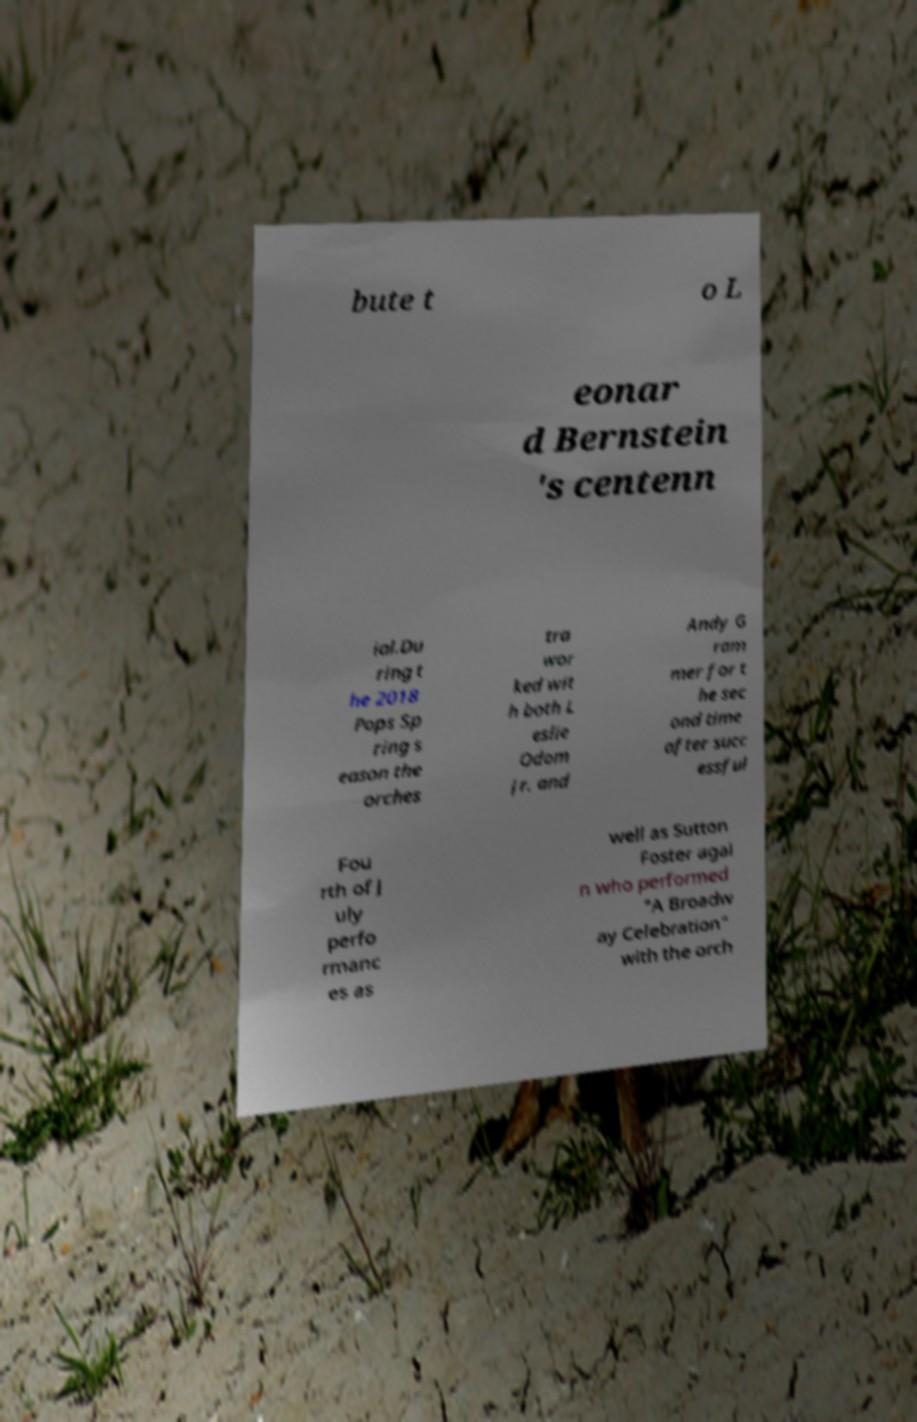Can you read and provide the text displayed in the image?This photo seems to have some interesting text. Can you extract and type it out for me? bute t o L eonar d Bernstein 's centenn ial.Du ring t he 2018 Pops Sp ring s eason the orches tra wor ked wit h both L eslie Odom Jr. and Andy G ram mer for t he sec ond time after succ essful Fou rth of J uly perfo rmanc es as well as Sutton Foster agai n who performed "A Broadw ay Celebration" with the orch 